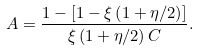Convert formula to latex. <formula><loc_0><loc_0><loc_500><loc_500>A = \frac { 1 - \left [ 1 - \xi \left ( 1 + \eta / 2 \right ) \right ] } { \xi \left ( 1 + \eta / 2 \right ) C } .</formula> 